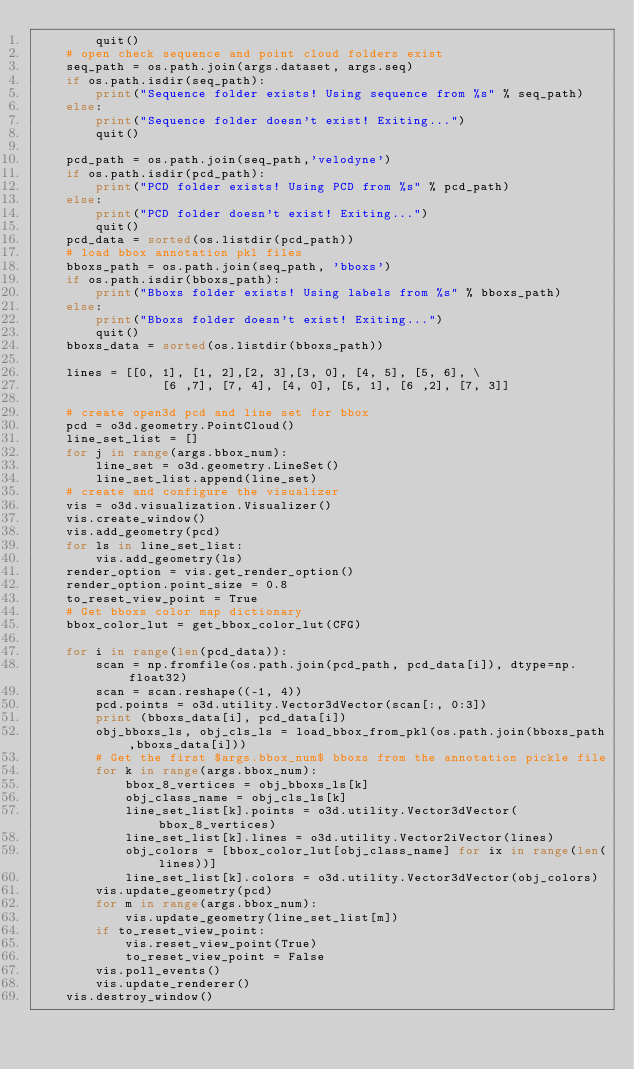Convert code to text. <code><loc_0><loc_0><loc_500><loc_500><_Python_>        quit()
    # open check sequence and point cloud folders exist
    seq_path = os.path.join(args.dataset, args.seq)
    if os.path.isdir(seq_path):
        print("Sequence folder exists! Using sequence from %s" % seq_path)
    else:
        print("Sequence folder doesn't exist! Exiting...")
        quit()
    
    pcd_path = os.path.join(seq_path,'velodyne')
    if os.path.isdir(pcd_path):
        print("PCD folder exists! Using PCD from %s" % pcd_path)
    else:
        print("PCD folder doesn't exist! Exiting...")
        quit()
    pcd_data = sorted(os.listdir(pcd_path))
    # load bbox annotation pkl files
    bboxs_path = os.path.join(seq_path, 'bboxs')
    if os.path.isdir(bboxs_path):
        print("Bboxs folder exists! Using labels from %s" % bboxs_path)
    else:
        print("Bboxs folder doesn't exist! Exiting...")
        quit()
    bboxs_data = sorted(os.listdir(bboxs_path))

    lines = [[0, 1], [1, 2],[2, 3],[3, 0], [4, 5], [5, 6], \
                 [6 ,7], [7, 4], [4, 0], [5, 1], [6 ,2], [7, 3]]
    
    # create open3d pcd and line set for bbox
    pcd = o3d.geometry.PointCloud()
    line_set_list = []
    for j in range(args.bbox_num):
        line_set = o3d.geometry.LineSet()
        line_set_list.append(line_set)
    # create and configure the visualizer
    vis = o3d.visualization.Visualizer()
    vis.create_window()
    vis.add_geometry(pcd)
    for ls in line_set_list:
        vis.add_geometry(ls)
    render_option = vis.get_render_option()
    render_option.point_size = 0.8
    to_reset_view_point = True
    # Get bboxs color map dictionary
    bbox_color_lut = get_bbox_color_lut(CFG)

    for i in range(len(pcd_data)):
        scan = np.fromfile(os.path.join(pcd_path, pcd_data[i]), dtype=np.float32)
        scan = scan.reshape((-1, 4))
        pcd.points = o3d.utility.Vector3dVector(scan[:, 0:3])
        print (bboxs_data[i], pcd_data[i])
        obj_bboxs_ls, obj_cls_ls = load_bbox_from_pkl(os.path.join(bboxs_path,bboxs_data[i]))
        # Get the first $args.bbox_num$ bboxs from the annotation pickle file
        for k in range(args.bbox_num):
            bbox_8_vertices = obj_bboxs_ls[k]
            obj_class_name = obj_cls_ls[k]
            line_set_list[k].points = o3d.utility.Vector3dVector(bbox_8_vertices)
            line_set_list[k].lines = o3d.utility.Vector2iVector(lines)
            obj_colors = [bbox_color_lut[obj_class_name] for ix in range(len(lines))]
            line_set_list[k].colors = o3d.utility.Vector3dVector(obj_colors)
        vis.update_geometry(pcd)
        for m in range(args.bbox_num):
            vis.update_geometry(line_set_list[m])
        if to_reset_view_point:
            vis.reset_view_point(True)
            to_reset_view_point = False
        vis.poll_events()
        vis.update_renderer()
    vis.destroy_window()
</code> 